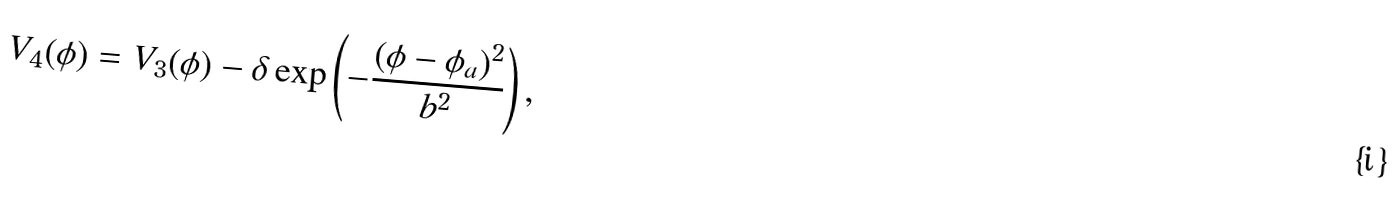<formula> <loc_0><loc_0><loc_500><loc_500>V _ { 4 } ( \phi ) = V _ { 3 } ( \phi ) - \delta \exp \left ( - \frac { ( \phi - \phi _ { a } ) ^ { 2 } } { b ^ { 2 } } \right ) ,</formula> 